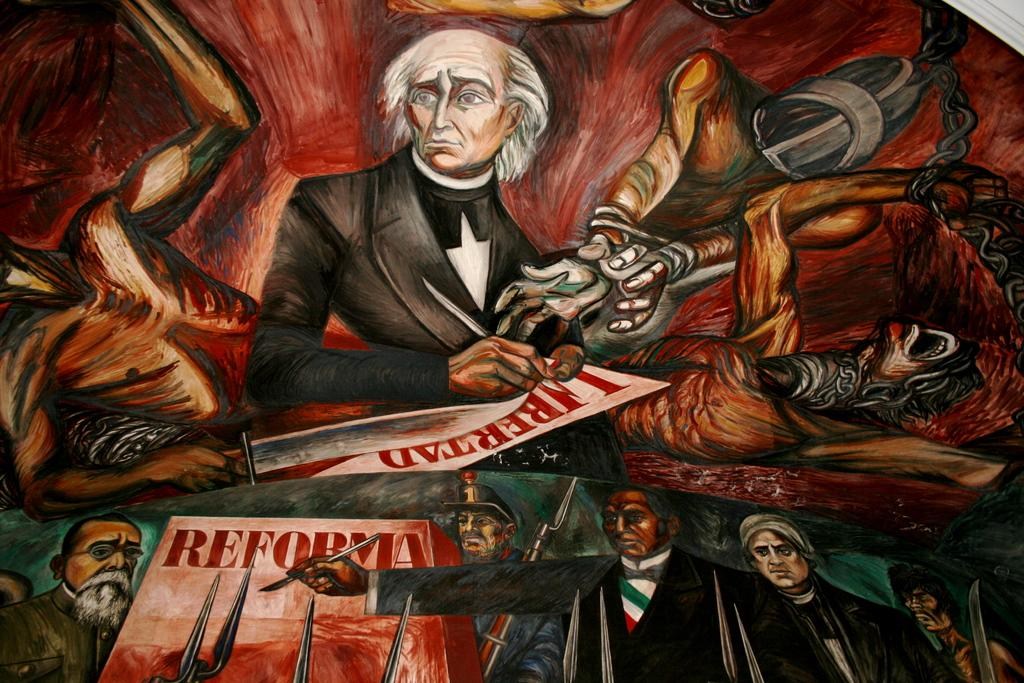Provide a one-sentence caption for the provided image. A painting features a group of men and the word Reforma. 